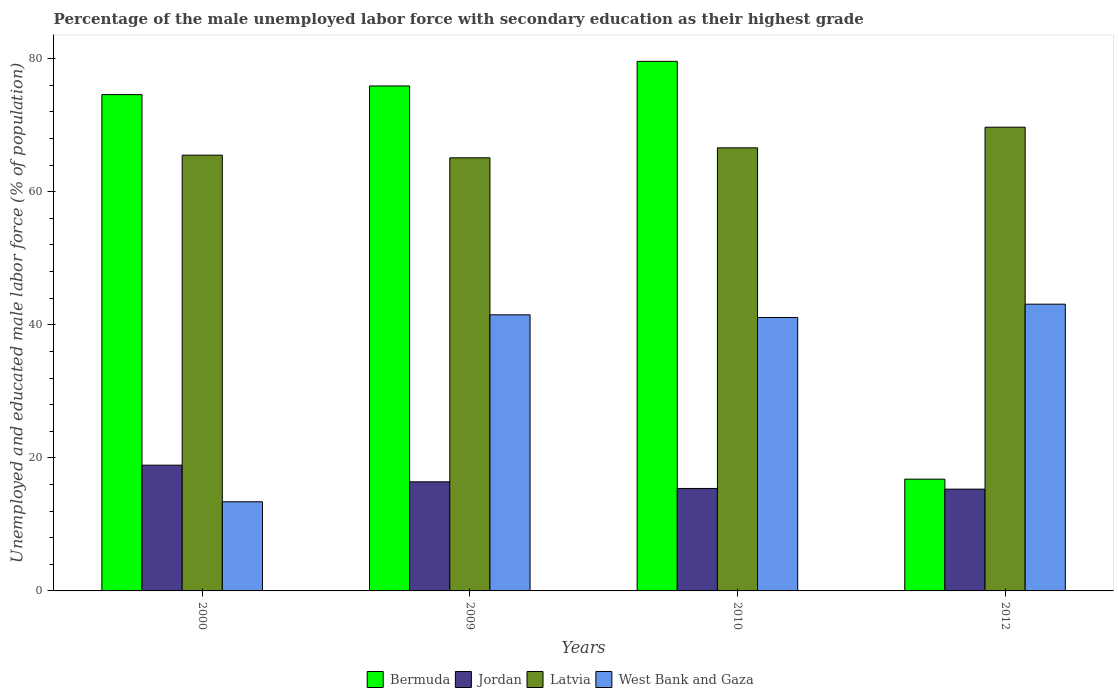How many groups of bars are there?
Offer a very short reply. 4. Are the number of bars on each tick of the X-axis equal?
Give a very brief answer. Yes. What is the label of the 2nd group of bars from the left?
Offer a very short reply. 2009. What is the percentage of the unemployed male labor force with secondary education in West Bank and Gaza in 2010?
Provide a succinct answer. 41.1. Across all years, what is the maximum percentage of the unemployed male labor force with secondary education in Bermuda?
Ensure brevity in your answer.  79.6. Across all years, what is the minimum percentage of the unemployed male labor force with secondary education in Bermuda?
Provide a succinct answer. 16.8. In which year was the percentage of the unemployed male labor force with secondary education in Bermuda minimum?
Your answer should be very brief. 2012. What is the total percentage of the unemployed male labor force with secondary education in Bermuda in the graph?
Provide a short and direct response. 246.9. What is the difference between the percentage of the unemployed male labor force with secondary education in Bermuda in 2000 and the percentage of the unemployed male labor force with secondary education in West Bank and Gaza in 2012?
Ensure brevity in your answer.  31.5. What is the average percentage of the unemployed male labor force with secondary education in Bermuda per year?
Your answer should be compact. 61.72. In the year 2000, what is the difference between the percentage of the unemployed male labor force with secondary education in Jordan and percentage of the unemployed male labor force with secondary education in Latvia?
Provide a succinct answer. -46.6. What is the ratio of the percentage of the unemployed male labor force with secondary education in Bermuda in 2000 to that in 2012?
Give a very brief answer. 4.44. Is the percentage of the unemployed male labor force with secondary education in Bermuda in 2010 less than that in 2012?
Give a very brief answer. No. Is the difference between the percentage of the unemployed male labor force with secondary education in Jordan in 2010 and 2012 greater than the difference between the percentage of the unemployed male labor force with secondary education in Latvia in 2010 and 2012?
Your answer should be compact. Yes. What is the difference between the highest and the second highest percentage of the unemployed male labor force with secondary education in West Bank and Gaza?
Provide a short and direct response. 1.6. What is the difference between the highest and the lowest percentage of the unemployed male labor force with secondary education in Jordan?
Offer a terse response. 3.6. In how many years, is the percentage of the unemployed male labor force with secondary education in Bermuda greater than the average percentage of the unemployed male labor force with secondary education in Bermuda taken over all years?
Ensure brevity in your answer.  3. What does the 1st bar from the left in 2010 represents?
Your answer should be very brief. Bermuda. What does the 3rd bar from the right in 2000 represents?
Make the answer very short. Jordan. Is it the case that in every year, the sum of the percentage of the unemployed male labor force with secondary education in Jordan and percentage of the unemployed male labor force with secondary education in Bermuda is greater than the percentage of the unemployed male labor force with secondary education in Latvia?
Provide a succinct answer. No. How many years are there in the graph?
Make the answer very short. 4. What is the difference between two consecutive major ticks on the Y-axis?
Offer a very short reply. 20. Are the values on the major ticks of Y-axis written in scientific E-notation?
Your answer should be compact. No. Does the graph contain any zero values?
Offer a terse response. No. Does the graph contain grids?
Offer a very short reply. No. How many legend labels are there?
Make the answer very short. 4. What is the title of the graph?
Ensure brevity in your answer.  Percentage of the male unemployed labor force with secondary education as their highest grade. Does "Solomon Islands" appear as one of the legend labels in the graph?
Ensure brevity in your answer.  No. What is the label or title of the Y-axis?
Provide a succinct answer. Unemployed and educated male labor force (% of population). What is the Unemployed and educated male labor force (% of population) of Bermuda in 2000?
Your answer should be very brief. 74.6. What is the Unemployed and educated male labor force (% of population) of Jordan in 2000?
Keep it short and to the point. 18.9. What is the Unemployed and educated male labor force (% of population) in Latvia in 2000?
Keep it short and to the point. 65.5. What is the Unemployed and educated male labor force (% of population) in West Bank and Gaza in 2000?
Keep it short and to the point. 13.4. What is the Unemployed and educated male labor force (% of population) in Bermuda in 2009?
Your answer should be compact. 75.9. What is the Unemployed and educated male labor force (% of population) in Jordan in 2009?
Your answer should be very brief. 16.4. What is the Unemployed and educated male labor force (% of population) in Latvia in 2009?
Offer a terse response. 65.1. What is the Unemployed and educated male labor force (% of population) of West Bank and Gaza in 2009?
Your answer should be compact. 41.5. What is the Unemployed and educated male labor force (% of population) of Bermuda in 2010?
Ensure brevity in your answer.  79.6. What is the Unemployed and educated male labor force (% of population) in Jordan in 2010?
Your answer should be compact. 15.4. What is the Unemployed and educated male labor force (% of population) in Latvia in 2010?
Provide a succinct answer. 66.6. What is the Unemployed and educated male labor force (% of population) in West Bank and Gaza in 2010?
Provide a short and direct response. 41.1. What is the Unemployed and educated male labor force (% of population) of Bermuda in 2012?
Ensure brevity in your answer.  16.8. What is the Unemployed and educated male labor force (% of population) in Jordan in 2012?
Provide a succinct answer. 15.3. What is the Unemployed and educated male labor force (% of population) in Latvia in 2012?
Offer a very short reply. 69.7. What is the Unemployed and educated male labor force (% of population) of West Bank and Gaza in 2012?
Ensure brevity in your answer.  43.1. Across all years, what is the maximum Unemployed and educated male labor force (% of population) in Bermuda?
Provide a short and direct response. 79.6. Across all years, what is the maximum Unemployed and educated male labor force (% of population) in Jordan?
Your answer should be compact. 18.9. Across all years, what is the maximum Unemployed and educated male labor force (% of population) in Latvia?
Provide a short and direct response. 69.7. Across all years, what is the maximum Unemployed and educated male labor force (% of population) of West Bank and Gaza?
Give a very brief answer. 43.1. Across all years, what is the minimum Unemployed and educated male labor force (% of population) of Bermuda?
Make the answer very short. 16.8. Across all years, what is the minimum Unemployed and educated male labor force (% of population) of Jordan?
Provide a short and direct response. 15.3. Across all years, what is the minimum Unemployed and educated male labor force (% of population) in Latvia?
Provide a short and direct response. 65.1. Across all years, what is the minimum Unemployed and educated male labor force (% of population) of West Bank and Gaza?
Make the answer very short. 13.4. What is the total Unemployed and educated male labor force (% of population) of Bermuda in the graph?
Your answer should be very brief. 246.9. What is the total Unemployed and educated male labor force (% of population) of Latvia in the graph?
Make the answer very short. 266.9. What is the total Unemployed and educated male labor force (% of population) of West Bank and Gaza in the graph?
Give a very brief answer. 139.1. What is the difference between the Unemployed and educated male labor force (% of population) in West Bank and Gaza in 2000 and that in 2009?
Keep it short and to the point. -28.1. What is the difference between the Unemployed and educated male labor force (% of population) in Bermuda in 2000 and that in 2010?
Provide a short and direct response. -5. What is the difference between the Unemployed and educated male labor force (% of population) in Latvia in 2000 and that in 2010?
Give a very brief answer. -1.1. What is the difference between the Unemployed and educated male labor force (% of population) in West Bank and Gaza in 2000 and that in 2010?
Provide a succinct answer. -27.7. What is the difference between the Unemployed and educated male labor force (% of population) in Bermuda in 2000 and that in 2012?
Your response must be concise. 57.8. What is the difference between the Unemployed and educated male labor force (% of population) in West Bank and Gaza in 2000 and that in 2012?
Offer a terse response. -29.7. What is the difference between the Unemployed and educated male labor force (% of population) in Latvia in 2009 and that in 2010?
Offer a very short reply. -1.5. What is the difference between the Unemployed and educated male labor force (% of population) of West Bank and Gaza in 2009 and that in 2010?
Your answer should be compact. 0.4. What is the difference between the Unemployed and educated male labor force (% of population) of Bermuda in 2009 and that in 2012?
Make the answer very short. 59.1. What is the difference between the Unemployed and educated male labor force (% of population) of West Bank and Gaza in 2009 and that in 2012?
Keep it short and to the point. -1.6. What is the difference between the Unemployed and educated male labor force (% of population) of Bermuda in 2010 and that in 2012?
Make the answer very short. 62.8. What is the difference between the Unemployed and educated male labor force (% of population) in West Bank and Gaza in 2010 and that in 2012?
Offer a terse response. -2. What is the difference between the Unemployed and educated male labor force (% of population) in Bermuda in 2000 and the Unemployed and educated male labor force (% of population) in Jordan in 2009?
Keep it short and to the point. 58.2. What is the difference between the Unemployed and educated male labor force (% of population) of Bermuda in 2000 and the Unemployed and educated male labor force (% of population) of Latvia in 2009?
Provide a short and direct response. 9.5. What is the difference between the Unemployed and educated male labor force (% of population) in Bermuda in 2000 and the Unemployed and educated male labor force (% of population) in West Bank and Gaza in 2009?
Your answer should be compact. 33.1. What is the difference between the Unemployed and educated male labor force (% of population) in Jordan in 2000 and the Unemployed and educated male labor force (% of population) in Latvia in 2009?
Give a very brief answer. -46.2. What is the difference between the Unemployed and educated male labor force (% of population) in Jordan in 2000 and the Unemployed and educated male labor force (% of population) in West Bank and Gaza in 2009?
Provide a succinct answer. -22.6. What is the difference between the Unemployed and educated male labor force (% of population) in Latvia in 2000 and the Unemployed and educated male labor force (% of population) in West Bank and Gaza in 2009?
Offer a terse response. 24. What is the difference between the Unemployed and educated male labor force (% of population) of Bermuda in 2000 and the Unemployed and educated male labor force (% of population) of Jordan in 2010?
Give a very brief answer. 59.2. What is the difference between the Unemployed and educated male labor force (% of population) of Bermuda in 2000 and the Unemployed and educated male labor force (% of population) of West Bank and Gaza in 2010?
Ensure brevity in your answer.  33.5. What is the difference between the Unemployed and educated male labor force (% of population) of Jordan in 2000 and the Unemployed and educated male labor force (% of population) of Latvia in 2010?
Provide a short and direct response. -47.7. What is the difference between the Unemployed and educated male labor force (% of population) of Jordan in 2000 and the Unemployed and educated male labor force (% of population) of West Bank and Gaza in 2010?
Ensure brevity in your answer.  -22.2. What is the difference between the Unemployed and educated male labor force (% of population) in Latvia in 2000 and the Unemployed and educated male labor force (% of population) in West Bank and Gaza in 2010?
Offer a very short reply. 24.4. What is the difference between the Unemployed and educated male labor force (% of population) of Bermuda in 2000 and the Unemployed and educated male labor force (% of population) of Jordan in 2012?
Your answer should be compact. 59.3. What is the difference between the Unemployed and educated male labor force (% of population) in Bermuda in 2000 and the Unemployed and educated male labor force (% of population) in Latvia in 2012?
Make the answer very short. 4.9. What is the difference between the Unemployed and educated male labor force (% of population) in Bermuda in 2000 and the Unemployed and educated male labor force (% of population) in West Bank and Gaza in 2012?
Ensure brevity in your answer.  31.5. What is the difference between the Unemployed and educated male labor force (% of population) in Jordan in 2000 and the Unemployed and educated male labor force (% of population) in Latvia in 2012?
Your answer should be very brief. -50.8. What is the difference between the Unemployed and educated male labor force (% of population) in Jordan in 2000 and the Unemployed and educated male labor force (% of population) in West Bank and Gaza in 2012?
Provide a succinct answer. -24.2. What is the difference between the Unemployed and educated male labor force (% of population) of Latvia in 2000 and the Unemployed and educated male labor force (% of population) of West Bank and Gaza in 2012?
Give a very brief answer. 22.4. What is the difference between the Unemployed and educated male labor force (% of population) in Bermuda in 2009 and the Unemployed and educated male labor force (% of population) in Jordan in 2010?
Keep it short and to the point. 60.5. What is the difference between the Unemployed and educated male labor force (% of population) of Bermuda in 2009 and the Unemployed and educated male labor force (% of population) of West Bank and Gaza in 2010?
Ensure brevity in your answer.  34.8. What is the difference between the Unemployed and educated male labor force (% of population) of Jordan in 2009 and the Unemployed and educated male labor force (% of population) of Latvia in 2010?
Keep it short and to the point. -50.2. What is the difference between the Unemployed and educated male labor force (% of population) of Jordan in 2009 and the Unemployed and educated male labor force (% of population) of West Bank and Gaza in 2010?
Keep it short and to the point. -24.7. What is the difference between the Unemployed and educated male labor force (% of population) of Bermuda in 2009 and the Unemployed and educated male labor force (% of population) of Jordan in 2012?
Offer a terse response. 60.6. What is the difference between the Unemployed and educated male labor force (% of population) of Bermuda in 2009 and the Unemployed and educated male labor force (% of population) of Latvia in 2012?
Your answer should be very brief. 6.2. What is the difference between the Unemployed and educated male labor force (% of population) of Bermuda in 2009 and the Unemployed and educated male labor force (% of population) of West Bank and Gaza in 2012?
Ensure brevity in your answer.  32.8. What is the difference between the Unemployed and educated male labor force (% of population) in Jordan in 2009 and the Unemployed and educated male labor force (% of population) in Latvia in 2012?
Offer a terse response. -53.3. What is the difference between the Unemployed and educated male labor force (% of population) of Jordan in 2009 and the Unemployed and educated male labor force (% of population) of West Bank and Gaza in 2012?
Your answer should be very brief. -26.7. What is the difference between the Unemployed and educated male labor force (% of population) of Latvia in 2009 and the Unemployed and educated male labor force (% of population) of West Bank and Gaza in 2012?
Provide a succinct answer. 22. What is the difference between the Unemployed and educated male labor force (% of population) in Bermuda in 2010 and the Unemployed and educated male labor force (% of population) in Jordan in 2012?
Offer a very short reply. 64.3. What is the difference between the Unemployed and educated male labor force (% of population) of Bermuda in 2010 and the Unemployed and educated male labor force (% of population) of Latvia in 2012?
Provide a succinct answer. 9.9. What is the difference between the Unemployed and educated male labor force (% of population) in Bermuda in 2010 and the Unemployed and educated male labor force (% of population) in West Bank and Gaza in 2012?
Give a very brief answer. 36.5. What is the difference between the Unemployed and educated male labor force (% of population) of Jordan in 2010 and the Unemployed and educated male labor force (% of population) of Latvia in 2012?
Your response must be concise. -54.3. What is the difference between the Unemployed and educated male labor force (% of population) in Jordan in 2010 and the Unemployed and educated male labor force (% of population) in West Bank and Gaza in 2012?
Ensure brevity in your answer.  -27.7. What is the difference between the Unemployed and educated male labor force (% of population) of Latvia in 2010 and the Unemployed and educated male labor force (% of population) of West Bank and Gaza in 2012?
Make the answer very short. 23.5. What is the average Unemployed and educated male labor force (% of population) of Bermuda per year?
Make the answer very short. 61.73. What is the average Unemployed and educated male labor force (% of population) of Jordan per year?
Provide a succinct answer. 16.5. What is the average Unemployed and educated male labor force (% of population) in Latvia per year?
Give a very brief answer. 66.72. What is the average Unemployed and educated male labor force (% of population) in West Bank and Gaza per year?
Offer a terse response. 34.77. In the year 2000, what is the difference between the Unemployed and educated male labor force (% of population) of Bermuda and Unemployed and educated male labor force (% of population) of Jordan?
Offer a very short reply. 55.7. In the year 2000, what is the difference between the Unemployed and educated male labor force (% of population) in Bermuda and Unemployed and educated male labor force (% of population) in Latvia?
Your answer should be very brief. 9.1. In the year 2000, what is the difference between the Unemployed and educated male labor force (% of population) in Bermuda and Unemployed and educated male labor force (% of population) in West Bank and Gaza?
Offer a very short reply. 61.2. In the year 2000, what is the difference between the Unemployed and educated male labor force (% of population) in Jordan and Unemployed and educated male labor force (% of population) in Latvia?
Your answer should be compact. -46.6. In the year 2000, what is the difference between the Unemployed and educated male labor force (% of population) in Latvia and Unemployed and educated male labor force (% of population) in West Bank and Gaza?
Provide a succinct answer. 52.1. In the year 2009, what is the difference between the Unemployed and educated male labor force (% of population) of Bermuda and Unemployed and educated male labor force (% of population) of Jordan?
Your answer should be very brief. 59.5. In the year 2009, what is the difference between the Unemployed and educated male labor force (% of population) in Bermuda and Unemployed and educated male labor force (% of population) in West Bank and Gaza?
Make the answer very short. 34.4. In the year 2009, what is the difference between the Unemployed and educated male labor force (% of population) of Jordan and Unemployed and educated male labor force (% of population) of Latvia?
Provide a short and direct response. -48.7. In the year 2009, what is the difference between the Unemployed and educated male labor force (% of population) of Jordan and Unemployed and educated male labor force (% of population) of West Bank and Gaza?
Ensure brevity in your answer.  -25.1. In the year 2009, what is the difference between the Unemployed and educated male labor force (% of population) of Latvia and Unemployed and educated male labor force (% of population) of West Bank and Gaza?
Your response must be concise. 23.6. In the year 2010, what is the difference between the Unemployed and educated male labor force (% of population) in Bermuda and Unemployed and educated male labor force (% of population) in Jordan?
Provide a succinct answer. 64.2. In the year 2010, what is the difference between the Unemployed and educated male labor force (% of population) of Bermuda and Unemployed and educated male labor force (% of population) of Latvia?
Your answer should be compact. 13. In the year 2010, what is the difference between the Unemployed and educated male labor force (% of population) of Bermuda and Unemployed and educated male labor force (% of population) of West Bank and Gaza?
Your answer should be compact. 38.5. In the year 2010, what is the difference between the Unemployed and educated male labor force (% of population) in Jordan and Unemployed and educated male labor force (% of population) in Latvia?
Give a very brief answer. -51.2. In the year 2010, what is the difference between the Unemployed and educated male labor force (% of population) of Jordan and Unemployed and educated male labor force (% of population) of West Bank and Gaza?
Keep it short and to the point. -25.7. In the year 2012, what is the difference between the Unemployed and educated male labor force (% of population) in Bermuda and Unemployed and educated male labor force (% of population) in Latvia?
Your response must be concise. -52.9. In the year 2012, what is the difference between the Unemployed and educated male labor force (% of population) in Bermuda and Unemployed and educated male labor force (% of population) in West Bank and Gaza?
Make the answer very short. -26.3. In the year 2012, what is the difference between the Unemployed and educated male labor force (% of population) of Jordan and Unemployed and educated male labor force (% of population) of Latvia?
Give a very brief answer. -54.4. In the year 2012, what is the difference between the Unemployed and educated male labor force (% of population) of Jordan and Unemployed and educated male labor force (% of population) of West Bank and Gaza?
Make the answer very short. -27.8. In the year 2012, what is the difference between the Unemployed and educated male labor force (% of population) of Latvia and Unemployed and educated male labor force (% of population) of West Bank and Gaza?
Your answer should be very brief. 26.6. What is the ratio of the Unemployed and educated male labor force (% of population) in Bermuda in 2000 to that in 2009?
Offer a terse response. 0.98. What is the ratio of the Unemployed and educated male labor force (% of population) in Jordan in 2000 to that in 2009?
Give a very brief answer. 1.15. What is the ratio of the Unemployed and educated male labor force (% of population) of Latvia in 2000 to that in 2009?
Give a very brief answer. 1.01. What is the ratio of the Unemployed and educated male labor force (% of population) in West Bank and Gaza in 2000 to that in 2009?
Your response must be concise. 0.32. What is the ratio of the Unemployed and educated male labor force (% of population) in Bermuda in 2000 to that in 2010?
Your answer should be very brief. 0.94. What is the ratio of the Unemployed and educated male labor force (% of population) of Jordan in 2000 to that in 2010?
Your answer should be compact. 1.23. What is the ratio of the Unemployed and educated male labor force (% of population) in Latvia in 2000 to that in 2010?
Give a very brief answer. 0.98. What is the ratio of the Unemployed and educated male labor force (% of population) in West Bank and Gaza in 2000 to that in 2010?
Ensure brevity in your answer.  0.33. What is the ratio of the Unemployed and educated male labor force (% of population) of Bermuda in 2000 to that in 2012?
Provide a short and direct response. 4.44. What is the ratio of the Unemployed and educated male labor force (% of population) of Jordan in 2000 to that in 2012?
Provide a succinct answer. 1.24. What is the ratio of the Unemployed and educated male labor force (% of population) of Latvia in 2000 to that in 2012?
Your response must be concise. 0.94. What is the ratio of the Unemployed and educated male labor force (% of population) of West Bank and Gaza in 2000 to that in 2012?
Your response must be concise. 0.31. What is the ratio of the Unemployed and educated male labor force (% of population) in Bermuda in 2009 to that in 2010?
Offer a very short reply. 0.95. What is the ratio of the Unemployed and educated male labor force (% of population) of Jordan in 2009 to that in 2010?
Your answer should be very brief. 1.06. What is the ratio of the Unemployed and educated male labor force (% of population) in Latvia in 2009 to that in 2010?
Make the answer very short. 0.98. What is the ratio of the Unemployed and educated male labor force (% of population) of West Bank and Gaza in 2009 to that in 2010?
Provide a succinct answer. 1.01. What is the ratio of the Unemployed and educated male labor force (% of population) in Bermuda in 2009 to that in 2012?
Ensure brevity in your answer.  4.52. What is the ratio of the Unemployed and educated male labor force (% of population) of Jordan in 2009 to that in 2012?
Your answer should be very brief. 1.07. What is the ratio of the Unemployed and educated male labor force (% of population) of Latvia in 2009 to that in 2012?
Your answer should be compact. 0.93. What is the ratio of the Unemployed and educated male labor force (% of population) of West Bank and Gaza in 2009 to that in 2012?
Provide a short and direct response. 0.96. What is the ratio of the Unemployed and educated male labor force (% of population) in Bermuda in 2010 to that in 2012?
Offer a terse response. 4.74. What is the ratio of the Unemployed and educated male labor force (% of population) of Latvia in 2010 to that in 2012?
Give a very brief answer. 0.96. What is the ratio of the Unemployed and educated male labor force (% of population) of West Bank and Gaza in 2010 to that in 2012?
Your answer should be very brief. 0.95. What is the difference between the highest and the second highest Unemployed and educated male labor force (% of population) of Latvia?
Give a very brief answer. 3.1. What is the difference between the highest and the lowest Unemployed and educated male labor force (% of population) in Bermuda?
Your answer should be compact. 62.8. What is the difference between the highest and the lowest Unemployed and educated male labor force (% of population) of Jordan?
Offer a terse response. 3.6. What is the difference between the highest and the lowest Unemployed and educated male labor force (% of population) in West Bank and Gaza?
Provide a short and direct response. 29.7. 